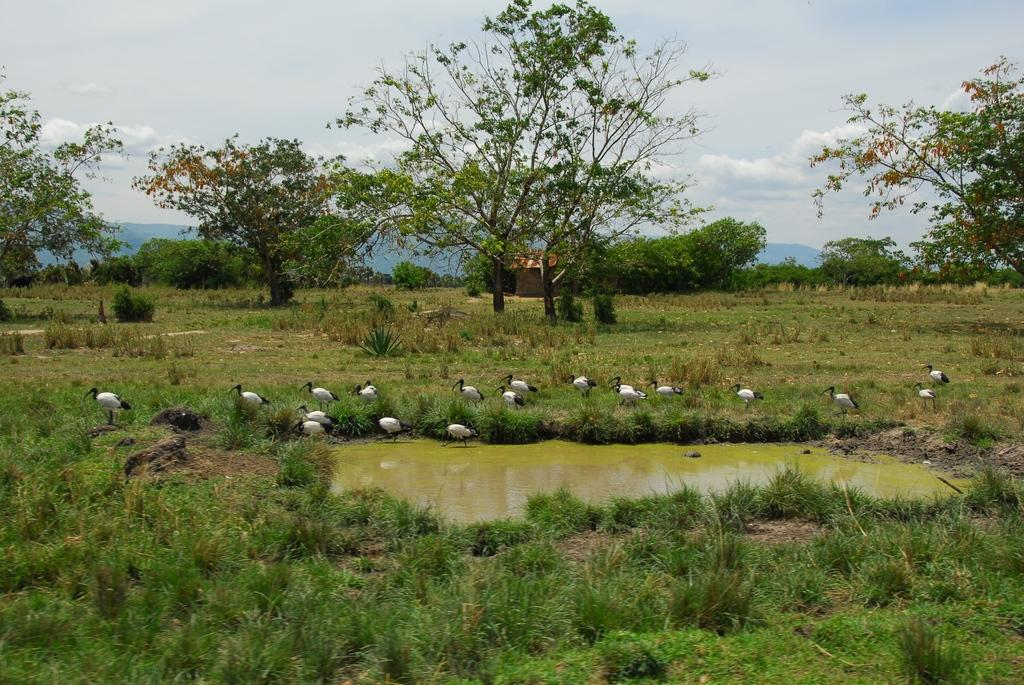What type of vegetation is present in the image? There is grass in the image. What animals can be seen on the ground in the image? There are birds standing on the ground in the image. What natural element is visible in the image? Water is visible in the image. What type of structure is visible in the background of the image? There is a house in the background of the image. What geographical feature is visible in the background of the image? There are mountains in the background of the image. What is visible in the sky in the background of the image? There are clouds in the sky in the background of the image. What sense can be seen in the image? There is no sense visible in the image; senses are not physical objects that can be seen. Is the sea visible in the image? No, the sea is not visible in the image; there is only water visible, which could be a river or lake. What is the temperature of the image? The temperature cannot be determined from the image; it is a visual representation and does not convey temperature information. 